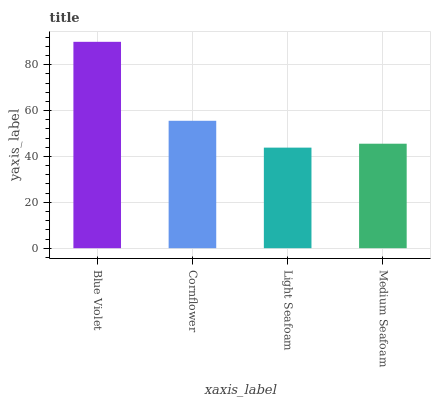Is Light Seafoam the minimum?
Answer yes or no. Yes. Is Blue Violet the maximum?
Answer yes or no. Yes. Is Cornflower the minimum?
Answer yes or no. No. Is Cornflower the maximum?
Answer yes or no. No. Is Blue Violet greater than Cornflower?
Answer yes or no. Yes. Is Cornflower less than Blue Violet?
Answer yes or no. Yes. Is Cornflower greater than Blue Violet?
Answer yes or no. No. Is Blue Violet less than Cornflower?
Answer yes or no. No. Is Cornflower the high median?
Answer yes or no. Yes. Is Medium Seafoam the low median?
Answer yes or no. Yes. Is Blue Violet the high median?
Answer yes or no. No. Is Blue Violet the low median?
Answer yes or no. No. 